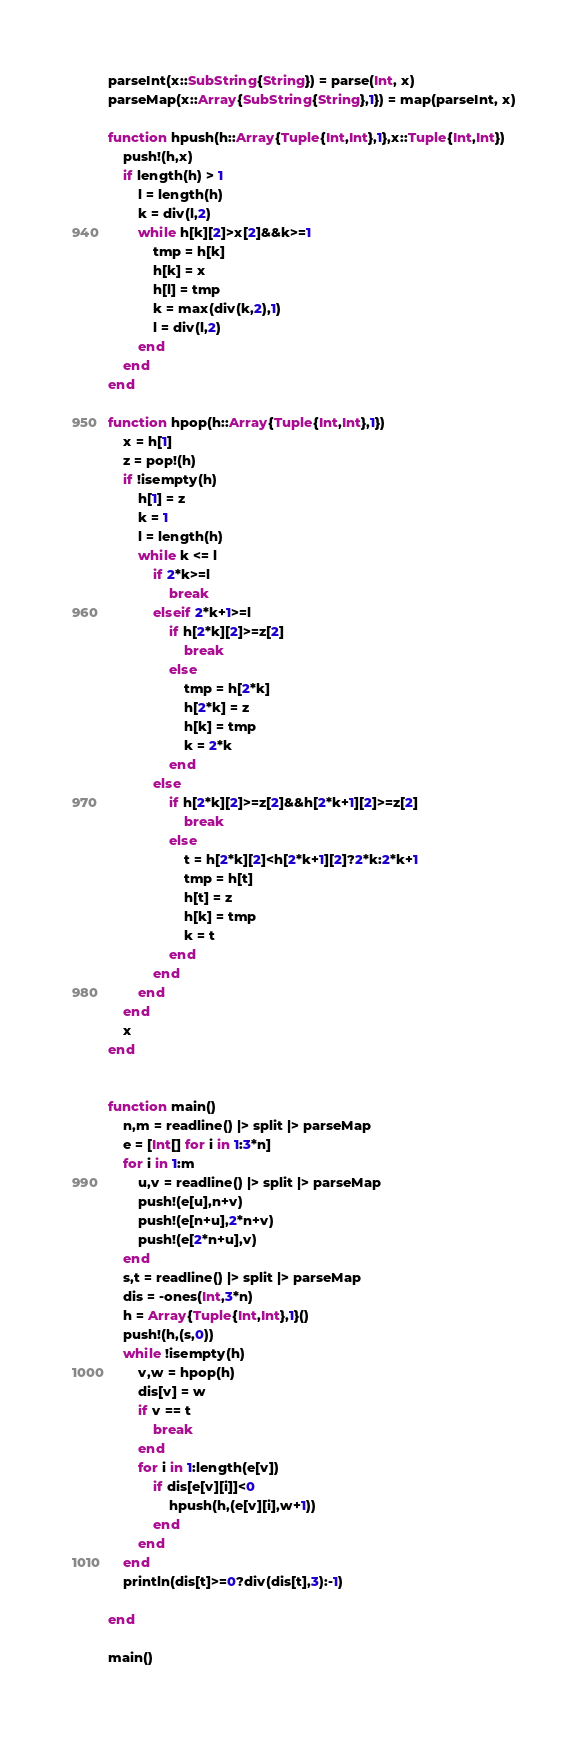Convert code to text. <code><loc_0><loc_0><loc_500><loc_500><_Julia_>parseInt(x::SubString{String}) = parse(Int, x)
parseMap(x::Array{SubString{String},1}) = map(parseInt, x)

function hpush(h::Array{Tuple{Int,Int},1},x::Tuple{Int,Int})
	push!(h,x)
	if length(h) > 1
		l = length(h)
		k = div(l,2)
		while h[k][2]>x[2]&&k>=1
			tmp = h[k]
			h[k] = x
			h[l] = tmp
			k = max(div(k,2),1)
			l = div(l,2)
		end
	end
end

function hpop(h::Array{Tuple{Int,Int},1})
	x = h[1]
	z = pop!(h)
	if !isempty(h)
		h[1] = z
		k = 1
		l = length(h)
		while k <= l
			if 2*k>=l
				break
			elseif 2*k+1>=l
				if h[2*k][2]>=z[2]
					break
				else
					tmp = h[2*k]
					h[2*k] = z
					h[k] = tmp
					k = 2*k
				end
			else
				if h[2*k][2]>=z[2]&&h[2*k+1][2]>=z[2]
					break
				else
					t = h[2*k][2]<h[2*k+1][2]?2*k:2*k+1
					tmp = h[t]
					h[t] = z
					h[k] = tmp
					k = t
				end
			end
		end
	end
	x
end


function main()
	n,m = readline() |> split |> parseMap
	e = [Int[] for i in 1:3*n]
	for i in 1:m
		u,v = readline() |> split |> parseMap
		push!(e[u],n+v)
		push!(e[n+u],2*n+v)
		push!(e[2*n+u],v)
	end
	s,t = readline() |> split |> parseMap
	dis = -ones(Int,3*n)
	h = Array{Tuple{Int,Int},1}()
	push!(h,(s,0))
	while !isempty(h)
		v,w = hpop(h)
		dis[v] = w
		if v == t
			break
		end
		for i in 1:length(e[v])
			if dis[e[v][i]]<0
				hpush(h,(e[v][i],w+1))
			end
		end
	end
	println(dis[t]>=0?div(dis[t],3):-1)

end

main()</code> 